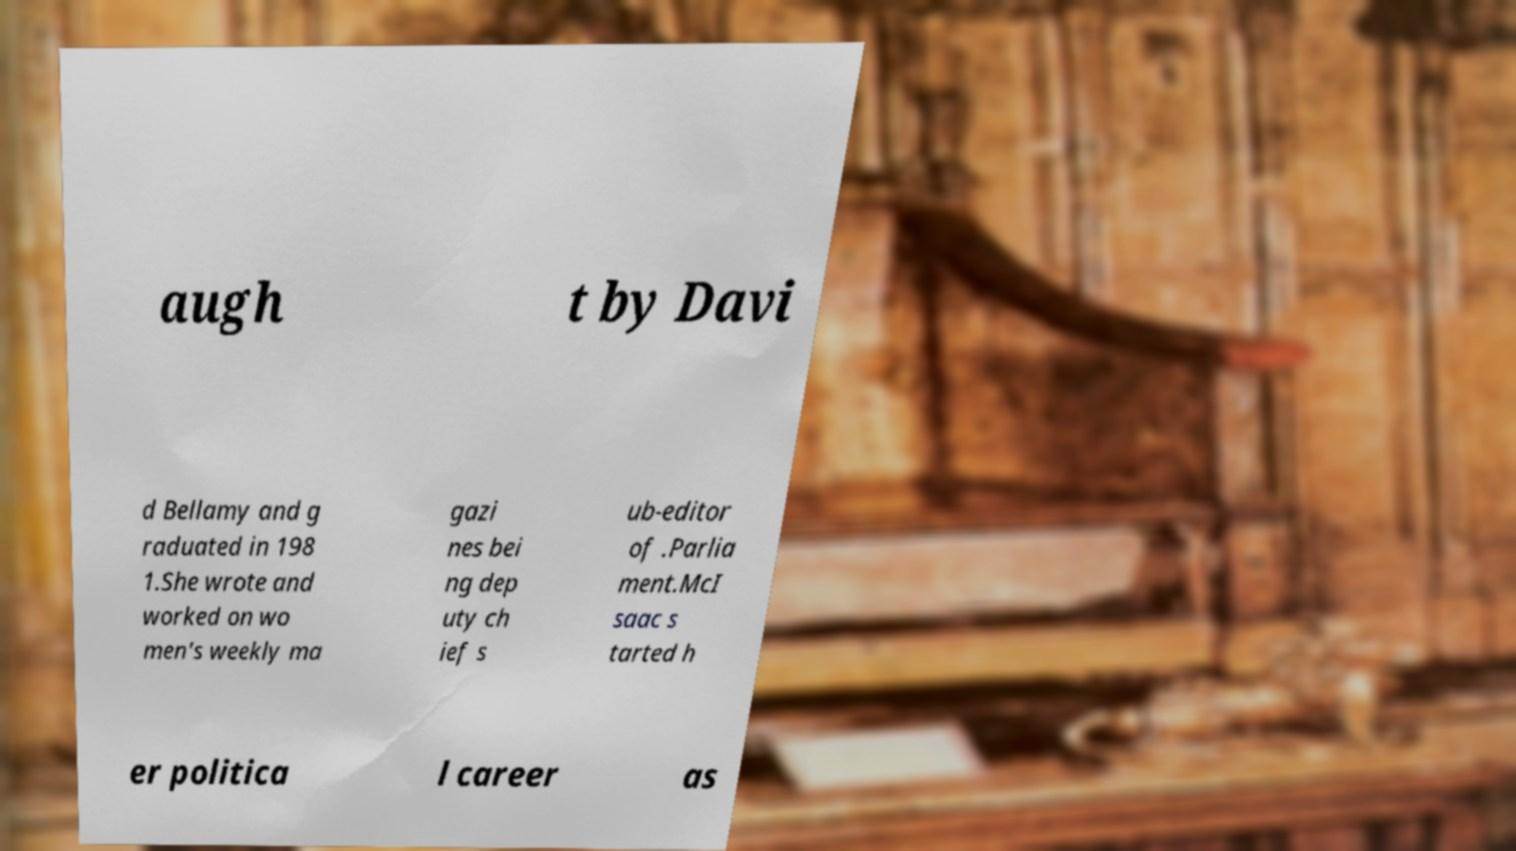For documentation purposes, I need the text within this image transcribed. Could you provide that? augh t by Davi d Bellamy and g raduated in 198 1.She wrote and worked on wo men's weekly ma gazi nes bei ng dep uty ch ief s ub-editor of .Parlia ment.McI saac s tarted h er politica l career as 